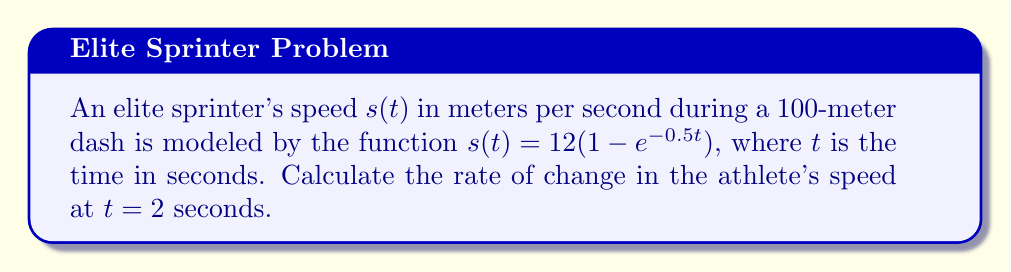Provide a solution to this math problem. To find the rate of change in the athlete's speed at $t = 2$ seconds, we need to calculate the derivative of the speed function $s(t)$ and evaluate it at $t = 2$.

Step 1: Find the derivative of $s(t)$.
$$\begin{align}
s(t) &= 12(1 - e^{-0.5t}) \\
\frac{d}{dt}[s(t)] &= \frac{d}{dt}[12 - 12e^{-0.5t}] \\
s'(t) &= 0 + 12 \cdot 0.5e^{-0.5t} \\
s'(t) &= 6e^{-0.5t}
\end{align}$$

Step 2: Evaluate $s'(t)$ at $t = 2$.
$$\begin{align}
s'(2) &= 6e^{-0.5(2)} \\
&= 6e^{-1} \\
&\approx 2.21 \text{ m/s}^2
\end{align}$$

The rate of change in the athlete's speed at $t = 2$ seconds is approximately 2.21 meters per second squared.
Answer: $2.21 \text{ m/s}^2$ 